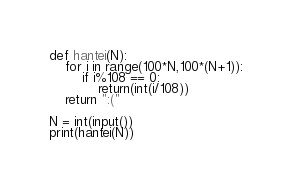<code> <loc_0><loc_0><loc_500><loc_500><_Python_>def hantei(N):
    for i in range(100*N,100*(N+1)):
        if i%108 == 0:
            return(int(i/108))
    return ":("

N = int(input())
print(hantei(N))</code> 